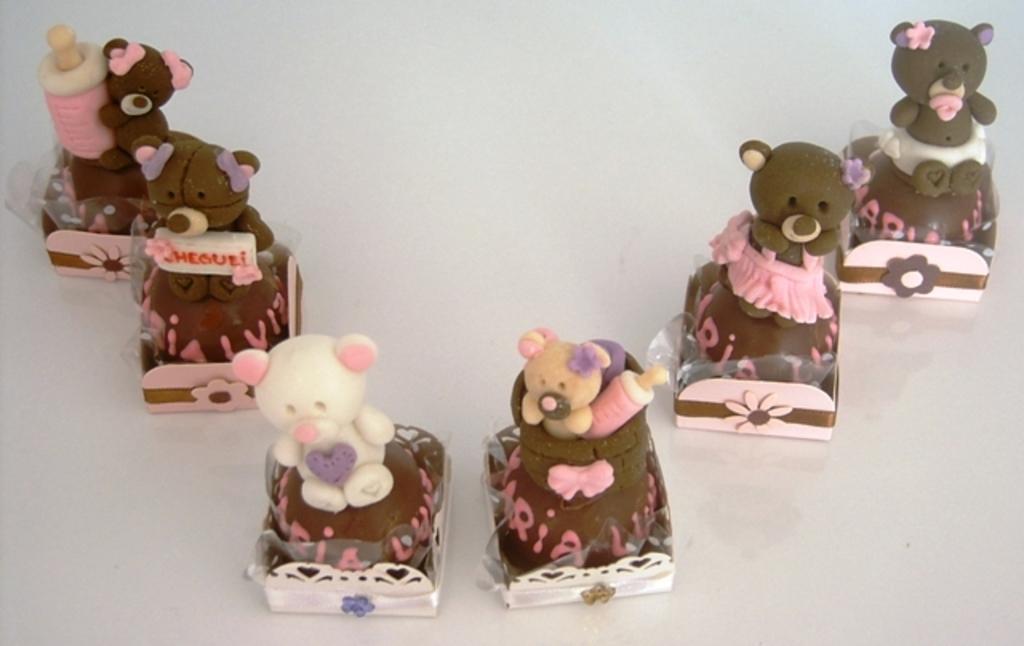Can you describe this image briefly? In this picture we can see many number of cupcakes are placed on a white color object and we can see the teddy bears and some bottles and we can see the text on the cupcakes. 